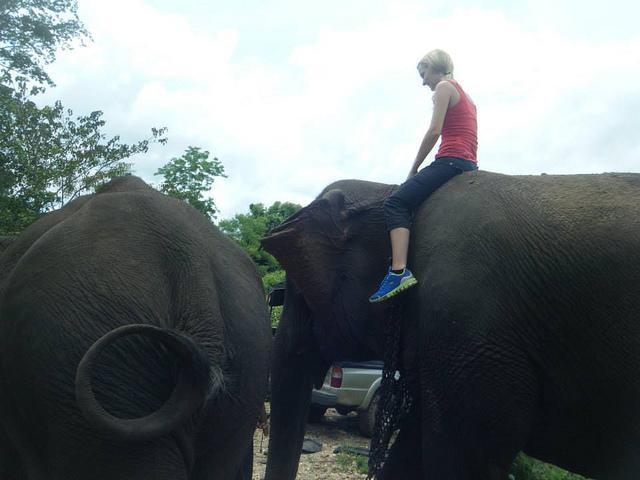How many elephants are there?
Give a very brief answer. 2. How many people are in the picture?
Give a very brief answer. 1. 